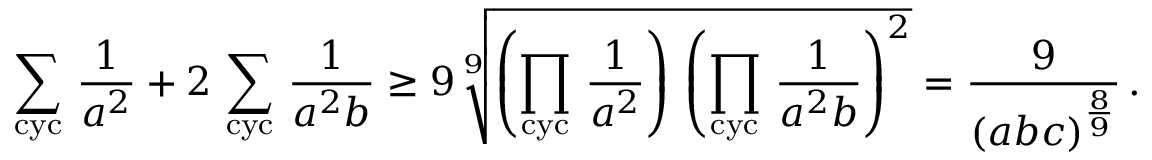Convert formula to latex. <formula><loc_0><loc_0><loc_500><loc_500>\sum _ { c y c } \, \frac { 1 } { a ^ { 2 } } + 2 \, \sum _ { c y c } \, \frac { 1 } { a ^ { 2 } b } \geq 9 \, \sqrt { [ } 9 ] { \left ( \prod _ { c y c } \, \frac { 1 } { a ^ { 2 } } \right ) \, \left ( \prod _ { c y c } \, \frac { 1 } { a ^ { 2 } b } \right ) ^ { 2 } } = \frac { 9 } { ( a b c ) ^ { \frac { 8 } { 9 } } } \, .</formula> 